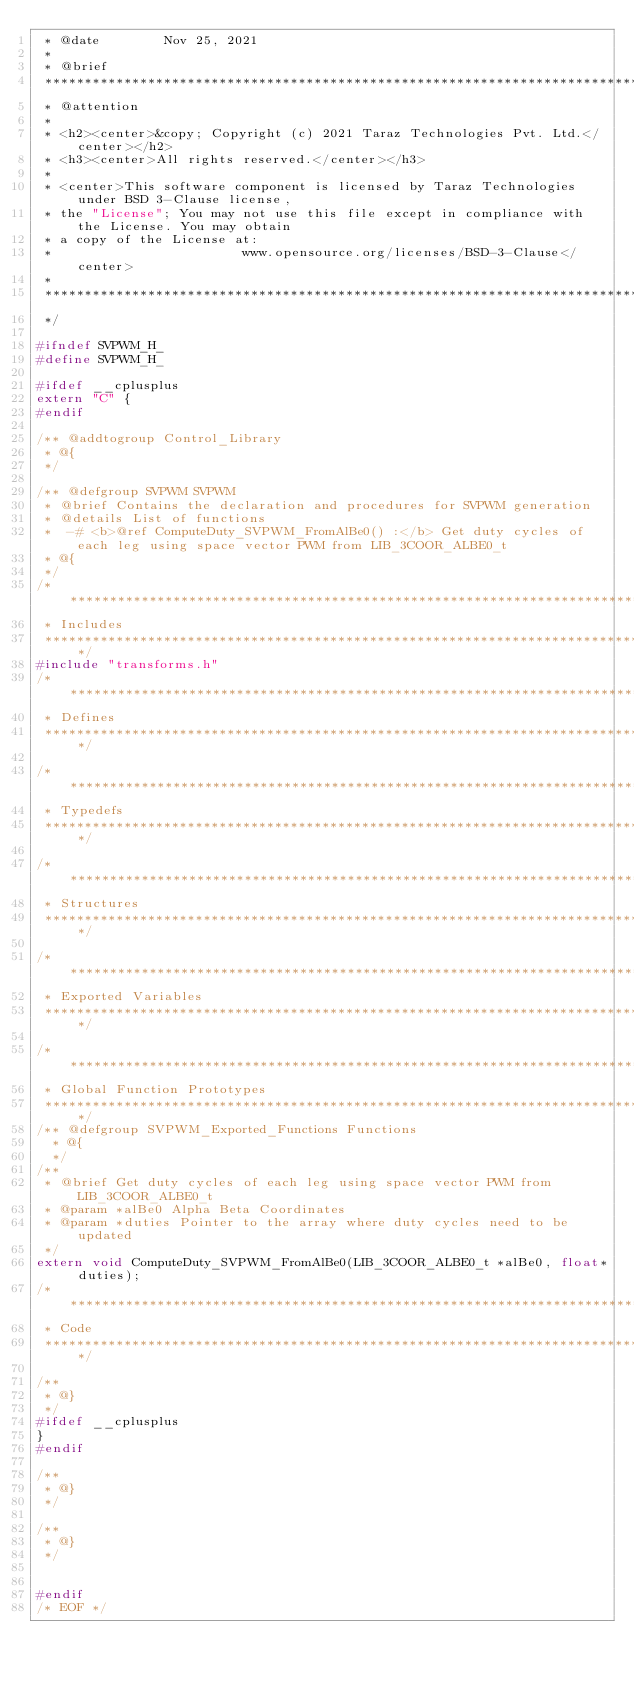Convert code to text. <code><loc_0><loc_0><loc_500><loc_500><_C_> * @date 		Nov 25, 2021
 *
 * @brief    
 ********************************************************************************
 * @attention
 *
 * <h2><center>&copy; Copyright (c) 2021 Taraz Technologies Pvt. Ltd.</center></h2>
 * <h3><center>All rights reserved.</center></h3>
 *
 * <center>This software component is licensed by Taraz Technologies under BSD 3-Clause license,
 * the "License"; You may not use this file except in compliance with the License. You may obtain 
 * a copy of the License at:
 *                        www.opensource.org/licenses/BSD-3-Clause</center>
 *
 ********************************************************************************
 */

#ifndef SVPWM_H_
#define SVPWM_H_

#ifdef __cplusplus
extern "C" {
#endif

/** @addtogroup Control_Library
 * @{
 */

/** @defgroup SVPWM SVPWM
 * @brief Contains the declaration and procedures for SVPWM generation
 * @details List of functions
 * 	-# <b>@ref ComputeDuty_SVPWM_FromAlBe0() :</b> Get duty cycles of each leg using space vector PWM from LIB_3COOR_ALBE0_t
 * @{
 */
/********************************************************************************
 * Includes
 *******************************************************************************/
#include "transforms.h"
/********************************************************************************
 * Defines
 *******************************************************************************/

/********************************************************************************
 * Typedefs
 *******************************************************************************/

/********************************************************************************
 * Structures
 *******************************************************************************/

/********************************************************************************
 * Exported Variables
 *******************************************************************************/

/********************************************************************************
 * Global Function Prototypes
 *******************************************************************************/
/** @defgroup SVPWM_Exported_Functions Functions
  * @{
  */
/**
 * @brief Get duty cycles of each leg using space vector PWM from LIB_3COOR_ALBE0_t
 * @param *alBe0 Alpha Beta Coordinates
 * @param *duties Pointer to the array where duty cycles need to be updated
 */
extern void ComputeDuty_SVPWM_FromAlBe0(LIB_3COOR_ALBE0_t *alBe0, float* duties);
/********************************************************************************
 * Code
 *******************************************************************************/

/**
 * @}
 */
#ifdef __cplusplus
}
#endif

/**
 * @}
 */

/**
 * @}
 */


#endif 
/* EOF */
</code> 